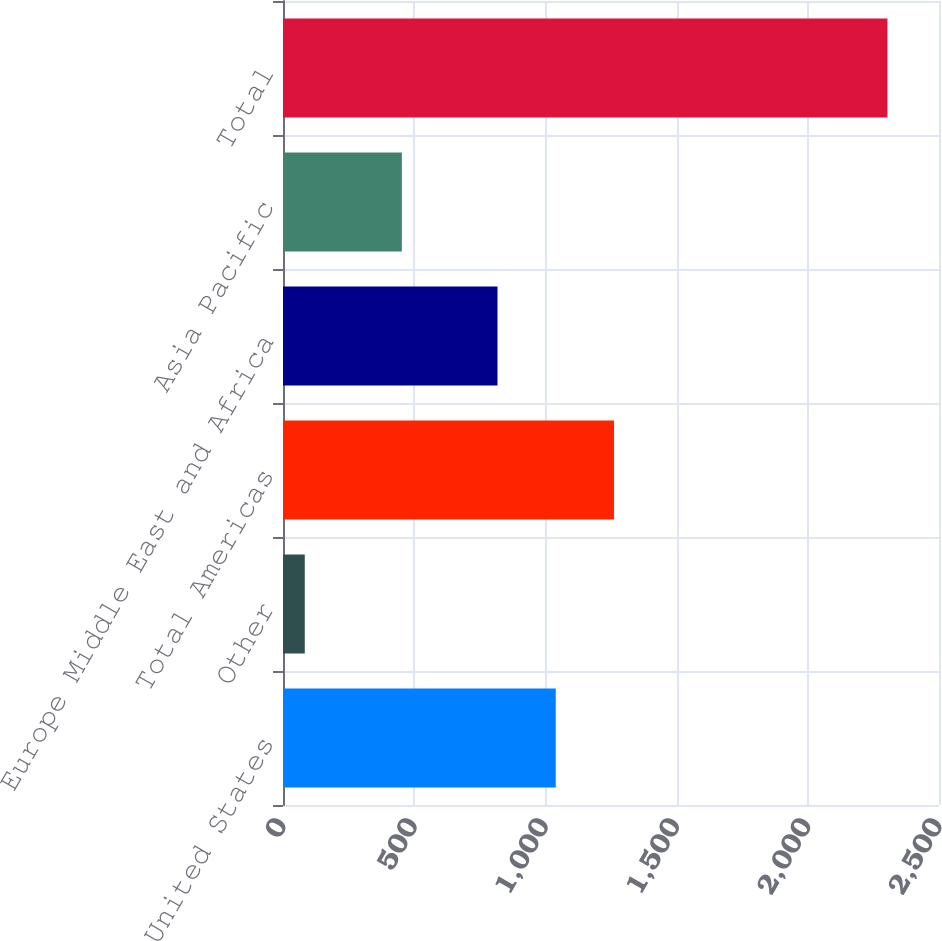Convert chart. <chart><loc_0><loc_0><loc_500><loc_500><bar_chart><fcel>United States<fcel>Other<fcel>Total Americas<fcel>Europe Middle East and Africa<fcel>Asia Pacific<fcel>Total<nl><fcel>1039.46<fcel>83<fcel>1261.52<fcel>817.4<fcel>452.9<fcel>2303.6<nl></chart> 